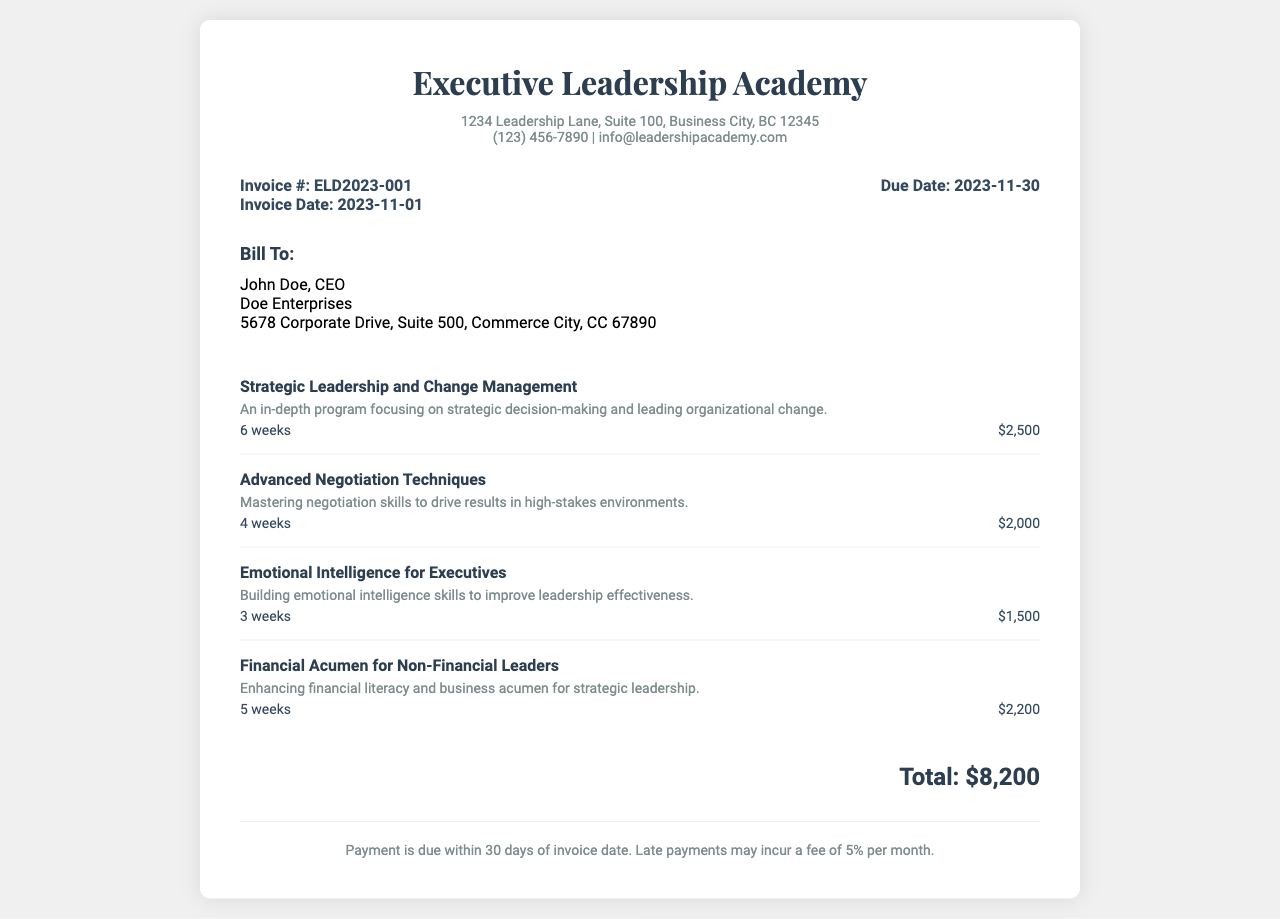What is the invoice number? The invoice number is specified in the document.
Answer: ELD2023-001 What is the total amount due? The total amount due is presented at the bottom of the invoice.
Answer: $8,200 Who is the billing contact? The billing contact's name is listed prominently in the billing information section.
Answer: John Doe What is the due date for payment? The due date is clearly stated in the invoice information.
Answer: 2023-11-30 How much is the fee for late payments? The fee for late payments is mentioned in the payment terms section of the invoice.
Answer: 5% per month What is the duration of the "Emotional Intelligence for Executives" course? The duration is listed next to the course name in the courses section.
Answer: 3 weeks What is the description of the "Advanced Negotiation Techniques" course? The description is provided right below the course name in the courses section.
Answer: Mastering negotiation skills to drive results in high-stakes environments How many courses are listed in the invoice? The total number of courses is counted in the courses section of the document.
Answer: 4 What is the address of the Executive Leadership Academy? The address is included in the header section of the invoice.
Answer: 1234 Leadership Lane, Suite 100, Business City, BC 12345 